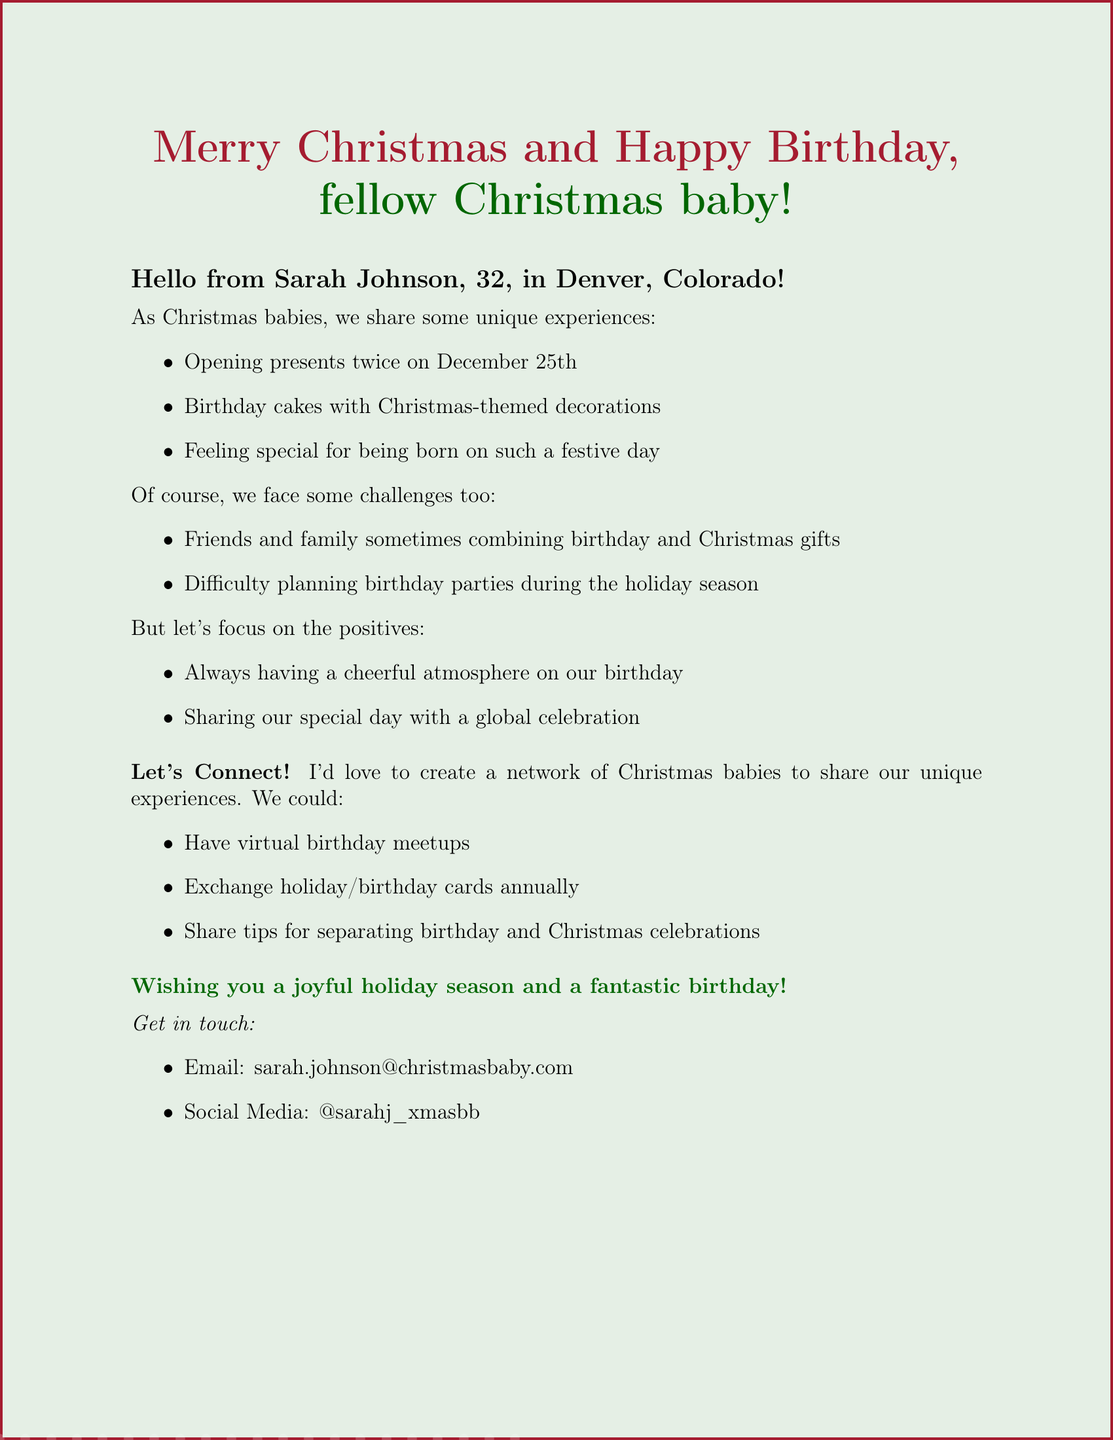What is the name of the sender? The sender of the greeting card is introduced as Sarah Johnson.
Answer: Sarah Johnson How old is Sarah? The document states Sarah's age as 32 years old.
Answer: 32 What is the location of the sender? Sarah Johnson mentions that she is located in Denver, Colorado.
Answer: Denver, Colorado What is one challenge mentioned in the document? The document lists challenges faced by Christmas babies, one of which is friends and family sometimes combining birthday and Christmas gifts.
Answer: Combining birthday and Christmas gifts What positive aspect is highlighted regarding being a Christmas baby? The document mentions a positive aspect being sharing a special day with a global celebration.
Answer: Global celebration What does Sarah propose as a connection activity? One proposed activity for connection is having virtual birthday meetups.
Answer: Virtual birthday meetups What season does Sarah wish the recipient happiness in? The closing message expresses wishes for a joyful holiday season.
Answer: Holiday season Where can Sarah be contacted via email? The document provides Sarah's email address for contact, which is sarah.johnson@christmasbaby.com.
Answer: sarah.johnson@christmasbaby.com What is the intended purpose of the greeting card? The purpose is to create a network of Christmas babies to share unique experiences.
Answer: Create a network of Christmas babies 